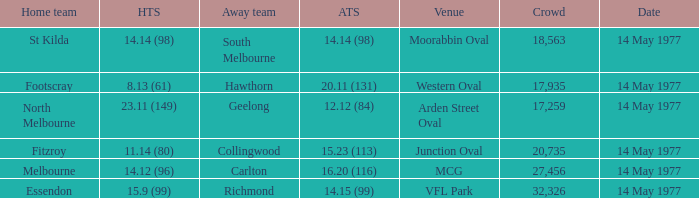Name the away team for essendon Richmond. 